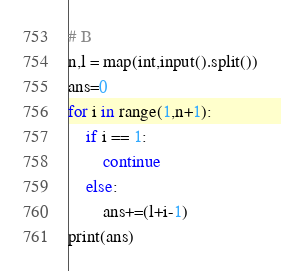<code> <loc_0><loc_0><loc_500><loc_500><_Python_># B
n,l = map(int,input().split())
ans=0
for i in range(1,n+1):
    if i == 1:
        continue
    else:
        ans+=(l+i-1)
print(ans)</code> 